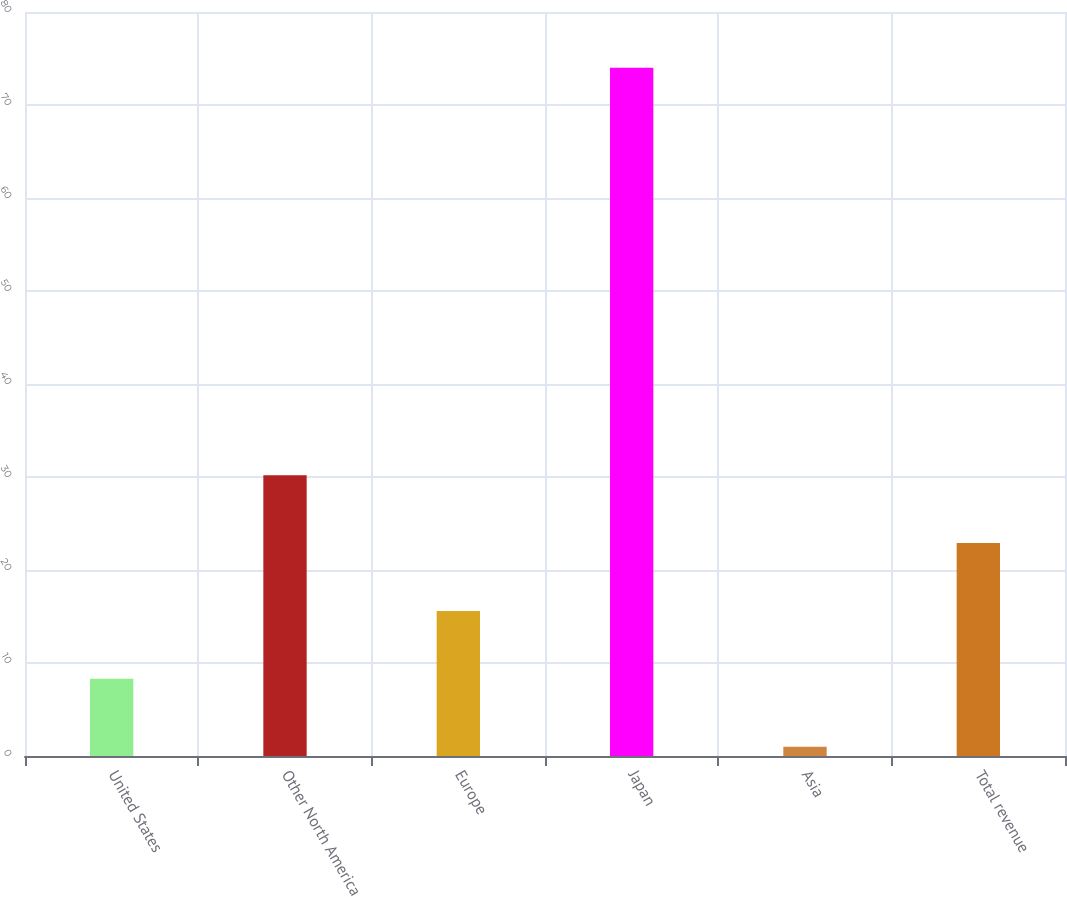Convert chart to OTSL. <chart><loc_0><loc_0><loc_500><loc_500><bar_chart><fcel>United States<fcel>Other North America<fcel>Europe<fcel>Japan<fcel>Asia<fcel>Total revenue<nl><fcel>8.3<fcel>30.2<fcel>15.6<fcel>74<fcel>1<fcel>22.9<nl></chart> 